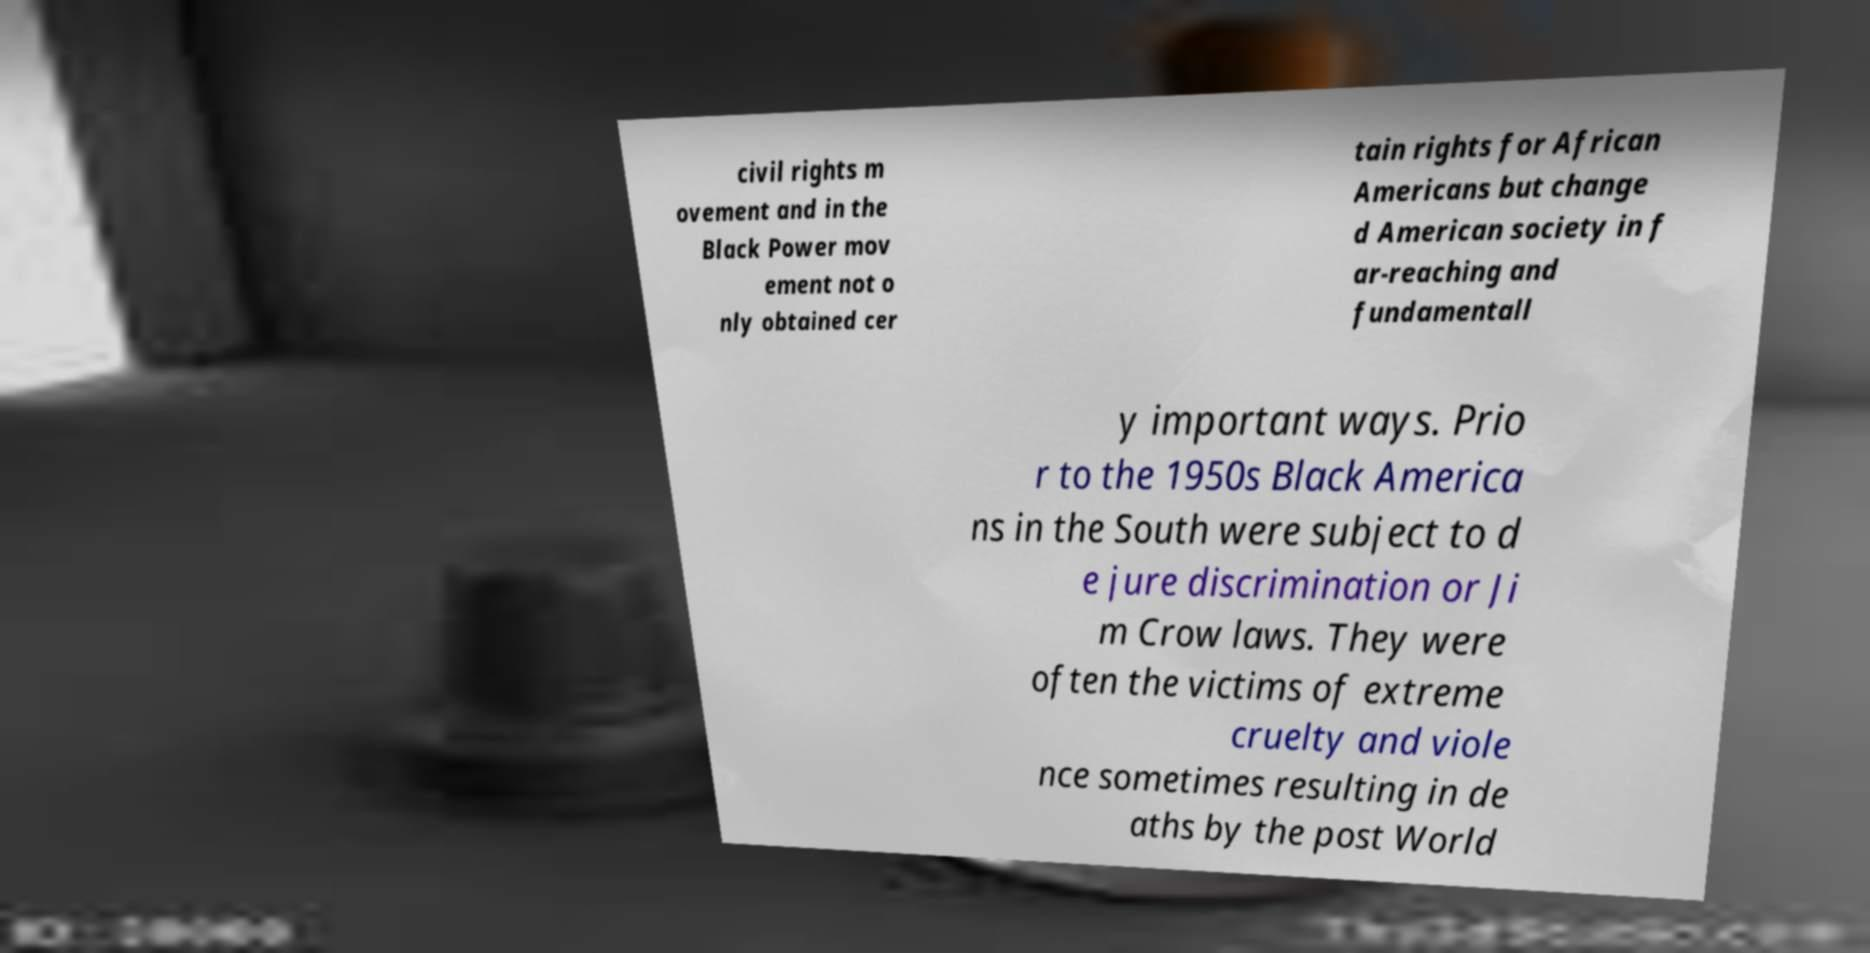What messages or text are displayed in this image? I need them in a readable, typed format. civil rights m ovement and in the Black Power mov ement not o nly obtained cer tain rights for African Americans but change d American society in f ar-reaching and fundamentall y important ways. Prio r to the 1950s Black America ns in the South were subject to d e jure discrimination or Ji m Crow laws. They were often the victims of extreme cruelty and viole nce sometimes resulting in de aths by the post World 